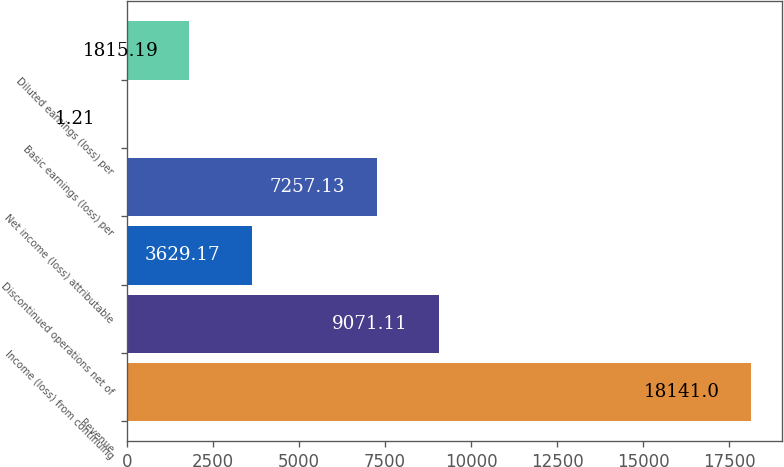Convert chart. <chart><loc_0><loc_0><loc_500><loc_500><bar_chart><fcel>Revenue<fcel>Income (loss) from continuing<fcel>Discontinued operations net of<fcel>Net income (loss) attributable<fcel>Basic earnings (loss) per<fcel>Diluted earnings (loss) per<nl><fcel>18141<fcel>9071.11<fcel>3629.17<fcel>7257.13<fcel>1.21<fcel>1815.19<nl></chart> 